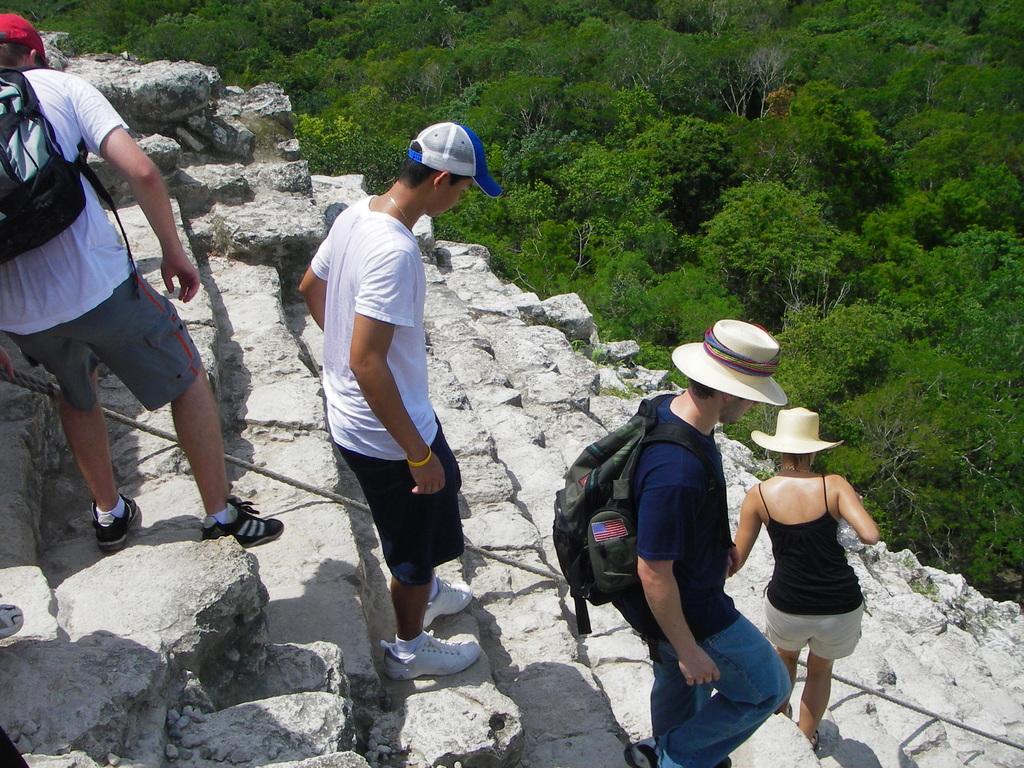Could you give a brief overview of what you see in this image? In this image we can see four persons on the stairs, among them, two are wearing the bags and there are some trees. 